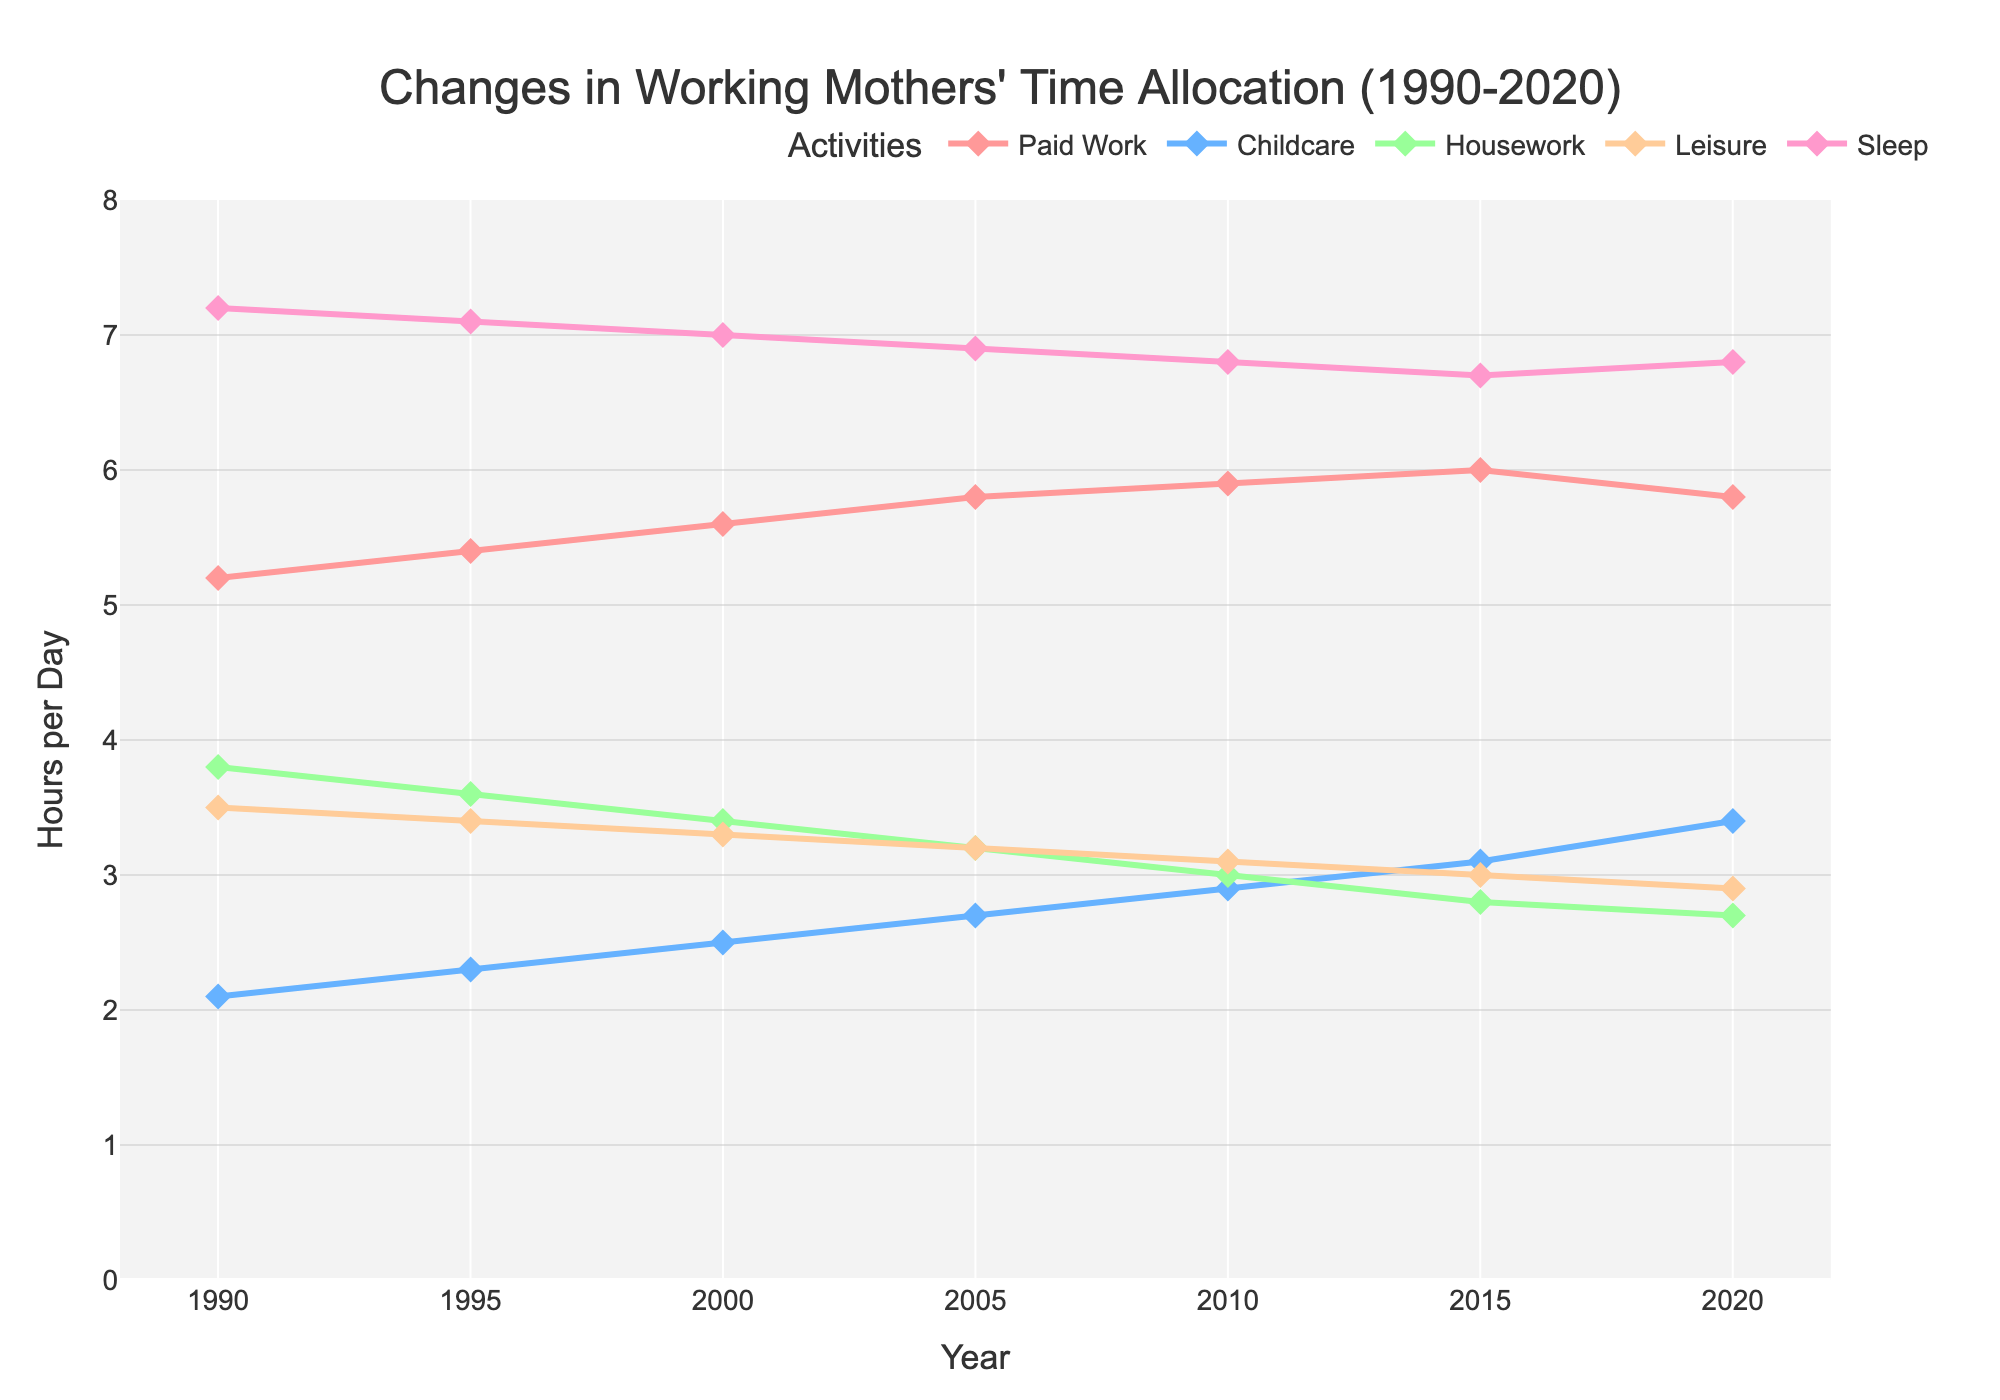What activity has increased the most in terms of hours per day from 1990 to 2020? To determine which activity has increased the most, calculate the difference in hours per day for each activity from 1990 to 2020. Paid Work increased from 5.2 to 5.8 (0.6), Childcare increased from 2.1 to 3.4 (1.3), Housework decreased from 3.8 to 2.7 (-1.1), Leisure decreased from 3.5 to 2.9 (-0.6), Sleep decreased from 7.2 to 6.8 (-0.4). Childcare has the largest increase.
Answer: Childcare By how many hours did Childcare time increase from 1990 to 2020? Subtract the hours per day spent on Childcare in 1990 from the hours spent in 2020. \(3.4 - 2.1 = 1.3\) hours
Answer: 1.3 hours In what year did working mothers spend the most time on Paid Work? From the graph, identify the peak of the Paid Work line. The highest value is 6.0 hours in 2015.
Answer: 2015 Compare the amount of time spent on Housework between 1990 and 2020. What difference do you observe? Subtract the hours per day spent on Housework in 2020 from the hours spent in 1990. \( 3.8 - 2.7 = 1.1 \) hours less in 2020.
Answer: 1.1 hours less Which activity has shown a consistent decrease over the years? From the graph, identify the trend lines. Housework, Leisure, and Sleep show a consistent decrease. Among these activities, Housework displays a uniform and ongoing decline.
Answer: Housework What is the combined total of hours spent on Leisure and Sleep in 2020? Add the hours per day spent on Leisure and Sleep in 2020. \(2.9 + 6.8 = 9.7\) hours
Answer: 9.7 hours How does the time spent on Paid Work in 1990 compare to the time spent on Paid Work in 2020? From the graph, check the values for Paid Work in 1990 and 2020. Subtract the 1990 value from the 2020 value. \(5.8 - 5.2 = 0.6\) hours more in 2020.
Answer: 0.6 hours more Did the time spent on Childcare ever equal the time spent on Housework between 1990 and 2020? Identify points on the graph where the Childcare and Housework lines intersect. There is no intersection point observed; they do not equal each other at any time.
Answer: No 